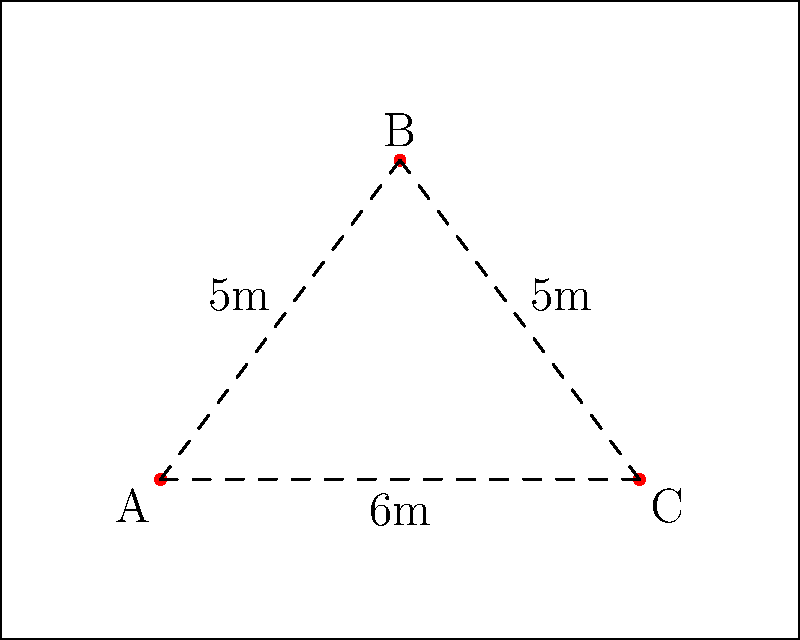In your restaurant kitchen, you have three main cooking stations (A, B, and C) that need to be connected efficiently. The distances between these stations are: A to B is 5m, B to C is 5m, and A to C is 6m. What is the minimum total length of connections needed to ensure all stations are linked, and which configuration achieves this? To solve this problem, we need to consider the concept of the minimum spanning tree in graph theory. Here's a step-by-step approach:

1. Understand the given information:
   - We have three cooking stations: A, B, and C
   - Distances: AB = 5m, BC = 5m, AC = 6m

2. Consider possible configurations:
   a) Connect all three stations: AB + BC + AC = 5 + 5 + 6 = 16m
   b) Connect only two pairs: AB + BC = 5 + 5 = 10m
   c) Connect only two pairs: AB + AC = 5 + 6 = 11m
   d) Connect only two pairs: BC + AC = 5 + 6 = 11m

3. Analyze the configurations:
   - Option (a) connects all stations but uses more length than necessary
   - Options (b), (c), and (d) all connect all stations indirectly
   - Option (b) uses the least total length

4. Apply the minimum spanning tree concept:
   The minimum spanning tree is the configuration that connects all points with the minimum total edge length. In this case, it's option (b).

5. Conclude:
   The minimum total length needed is 10m, achieved by connecting AB and BC.

This configuration ensures all stations are connected (A to C through B) while minimizing the total connection length, which is crucial for efficient movement and resource utilization in a busy restaurant kitchen.
Answer: 10m, connecting AB and BC 